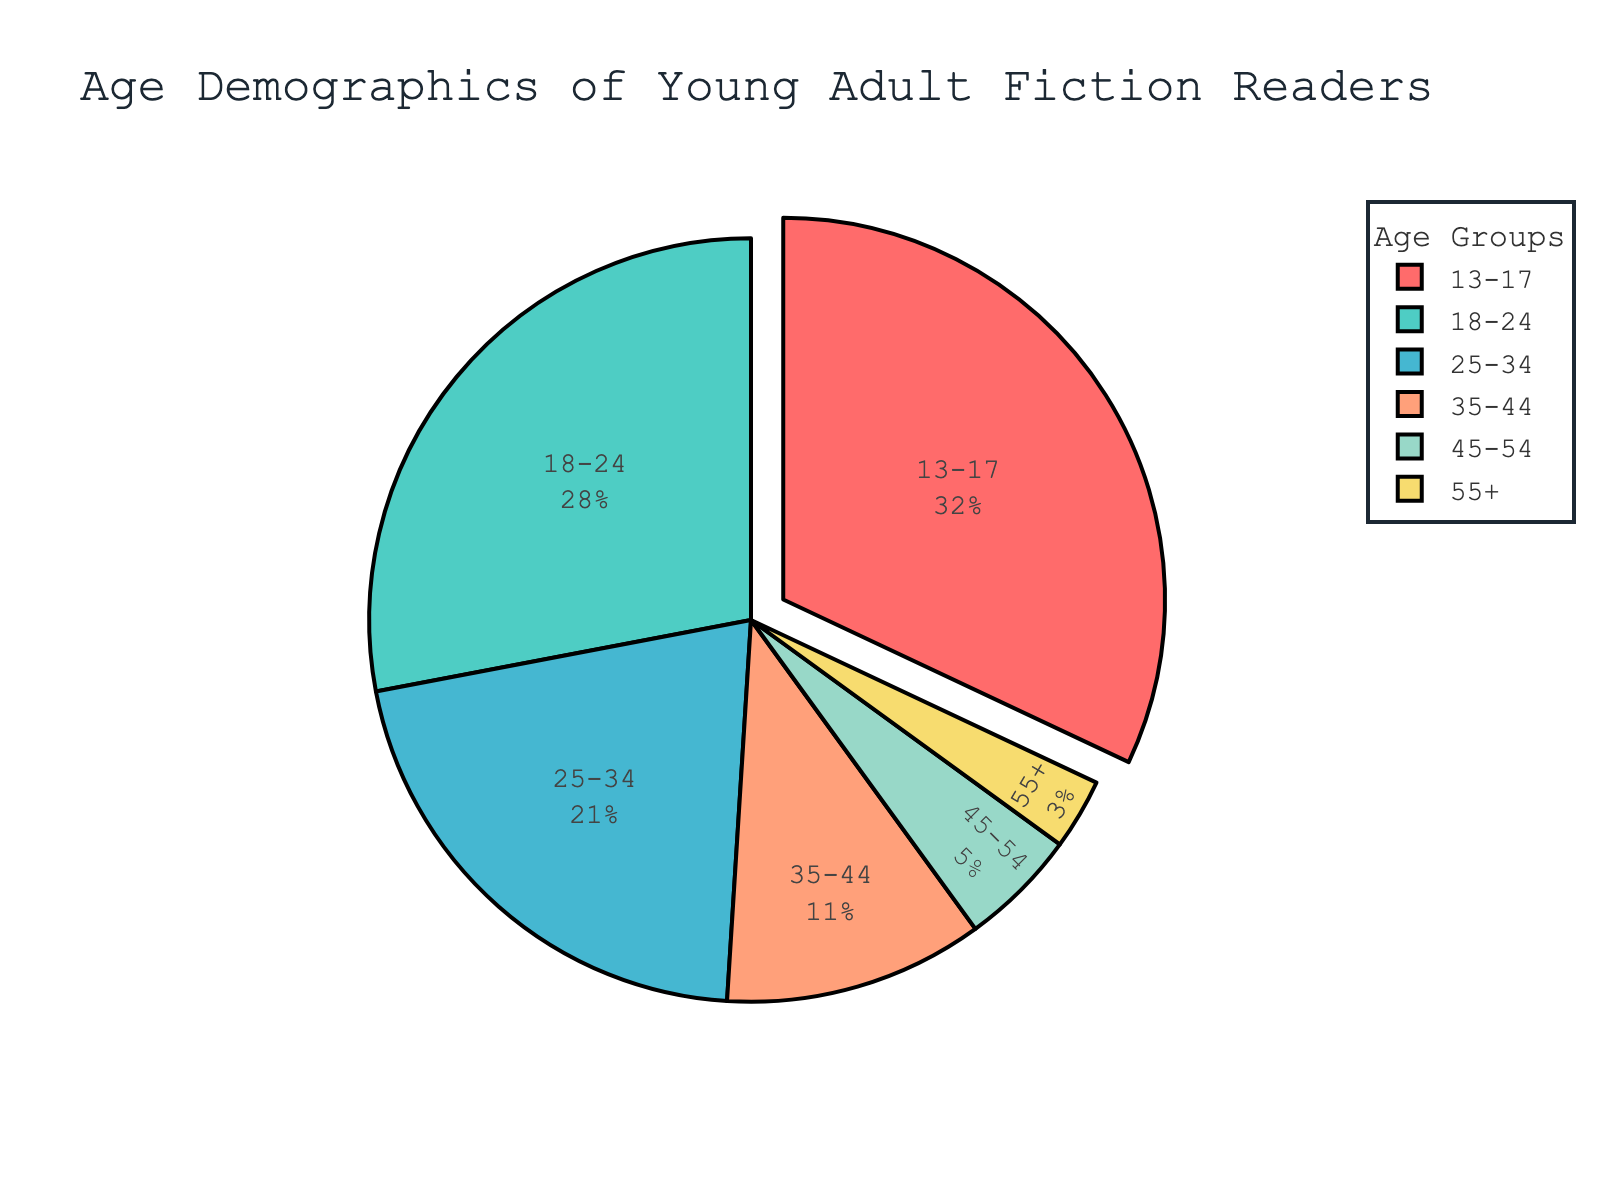What's the largest age group of young adult fiction readers? The largest age group can be identified by looking at the slice of the pie chart that is pulled out, which is the '13-17' age group. This is also indicated in the legend.
Answer: 13-17 Which age group has the smallest representation among young adult fiction readers? The smallest slice in the pie chart, which is the '55+' age group, represents the smallest percentage of the readers, as seen in the pie chart and its corresponding legend.
Answer: 55+ What is the combined percentage of readers aged 25-34 and 35-44? To find the combined percentage, sum the percentages of the age groups 25-34 and 35-44. Specifically, 21% (25-34) + 11% (35-44) = 32%.
Answer: 32% How does the percentage of readers aged 18-24 compare to those aged 45-54? Comparing the two slices of the pie chart for these age groups, 18-24 represents 28%, which is significantly larger than the 5% represented by age 45-54.
Answer: More What color is used to represent the '18-24' age group? The '18-24' age group is indicated by the second slice of the pie chart, which is colored in blue based on the provided color palette.
Answer: Blue Among the provided age groups, which two groups combined make up less than 10% of the readers? By examining the slices and percentages, age groups '45-54' (5%) and '55+' (3%) combined sum up to 8%, which is less than 10%.
Answer: 45-54 and 55+ By how much is the percentage of readers aged 13-17 higher than those aged 35-44? To find the difference, subtract the percentage of the age group 35-44 (11%) from 13-17 (32%). Specifically, 32% - 11% = 21%.
Answer: 21% What proportion of readers are aged between 18 and 34? To get the proportion, sum the percentages of the age groups 18-24 (28%) and 25-34 (21%). Specifically, 28% + 21% = 49%.
Answer: 49% Is there a tie among any age groups in terms of their percentage of readers? No, each slice in the pie chart has a unique percentage value, so there is no tie between any age groups.
Answer: No 